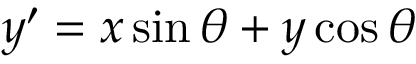Convert formula to latex. <formula><loc_0><loc_0><loc_500><loc_500>y ^ { \prime } = x \sin \theta + y \cos \theta</formula> 